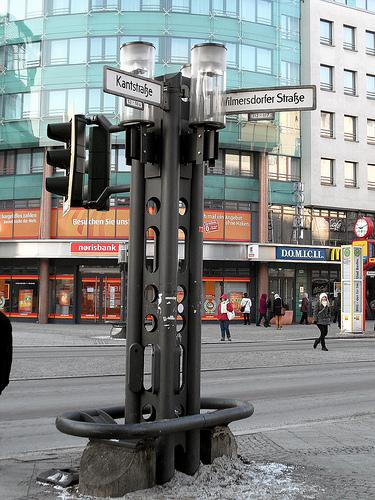Question: how are people dressed?
Choices:
A. Bathing suits.
B. T-shirts.
C. Warmly.
D. Suits.
Answer with the letter. Answer: C Question: when will people cross the street?
Choices:
A. When more people have gathered.
B. When it starts to rain.
C. When there are no cars in the way.
D. The traffic signal indicate it is OK.
Answer with the letter. Answer: D Question: who is wearing a white hat?
Choices:
A. The truck driver.
B. The chauffeur.
C. A pedestrian.
D. The bicyclist.
Answer with the letter. Answer: C Question: where is a clock?
Choices:
A. Across the street.
B. In the kitchen.
C. In the classroom.
D. In the bakery.
Answer with the letter. Answer: A 